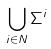<formula> <loc_0><loc_0><loc_500><loc_500>\bigcup _ { i \in N } \Sigma ^ { i }</formula> 